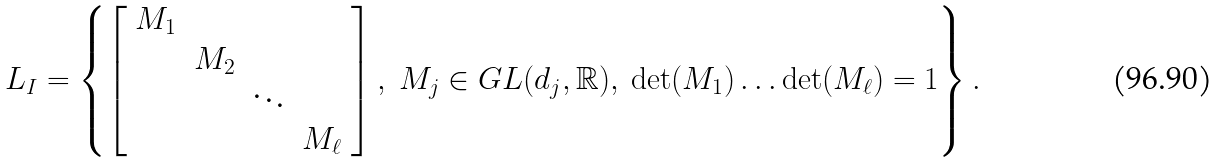<formula> <loc_0><loc_0><loc_500><loc_500>L _ { I } = \left \{ \left [ \begin{array} { c c c c } M _ { 1 } \\ & M _ { 2 } \\ & & \ddots \\ & & & M _ { \ell } \end{array} \right ] , \ M _ { j } \in G L ( d _ { j } , \mathbb { R } ) , \ \det ( M _ { 1 } ) \dots \det ( M _ { \ell } ) = 1 \right \} .</formula> 